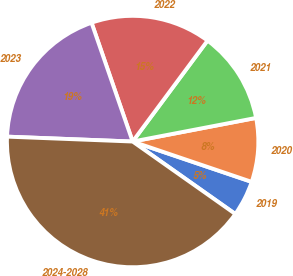<chart> <loc_0><loc_0><loc_500><loc_500><pie_chart><fcel>2019<fcel>2020<fcel>2021<fcel>2022<fcel>2023<fcel>2024-2028<nl><fcel>4.58%<fcel>8.21%<fcel>11.83%<fcel>15.46%<fcel>19.08%<fcel>40.84%<nl></chart> 